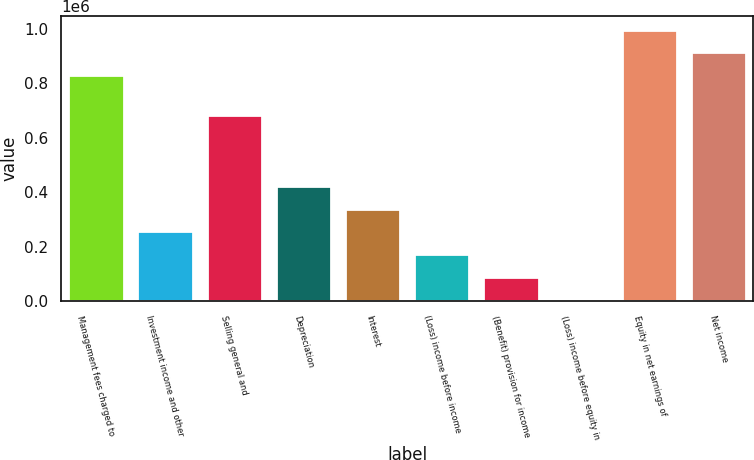Convert chart to OTSL. <chart><loc_0><loc_0><loc_500><loc_500><bar_chart><fcel>Management fees charged to<fcel>Investment income and other<fcel>Selling general and<fcel>Depreciation<fcel>Interest<fcel>(Loss) income before income<fcel>(Benefit) provision for income<fcel>(Loss) income before equity in<fcel>Equity in net earnings of<fcel>Net income<nl><fcel>829515<fcel>255980<fcel>683562<fcel>422717<fcel>339349<fcel>172612<fcel>89243.4<fcel>5875<fcel>996252<fcel>912883<nl></chart> 